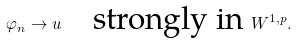<formula> <loc_0><loc_0><loc_500><loc_500>\varphi _ { n } \to u \quad \text {strongly in } W ^ { 1 , p } .</formula> 